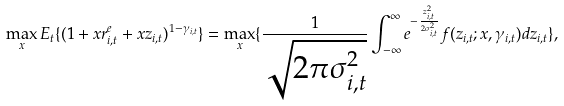Convert formula to latex. <formula><loc_0><loc_0><loc_500><loc_500>\max _ { x } E _ { t } \{ ( 1 + x r ^ { e } _ { i , t } + x z _ { i , t } ) ^ { 1 - \gamma _ { i , t } } \} = \max _ { x } \{ \frac { 1 } { \sqrt { 2 \pi \sigma _ { i , t } ^ { 2 } } } \int _ { - \infty } ^ { \infty } e ^ { - \frac { z _ { i , t } ^ { 2 } } { 2 \sigma _ { i , t } ^ { 2 } } } f ( z _ { i , t } ; x , \gamma _ { i , t } ) d z _ { i , t } \} ,</formula> 